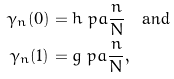<formula> <loc_0><loc_0><loc_500><loc_500>\gamma _ { n } ( 0 ) & = h \ p a { \frac { n } { N } } \quad \text {and} \\ \gamma _ { n } ( 1 ) & = g \ p a { \frac { n } { N } } ,</formula> 